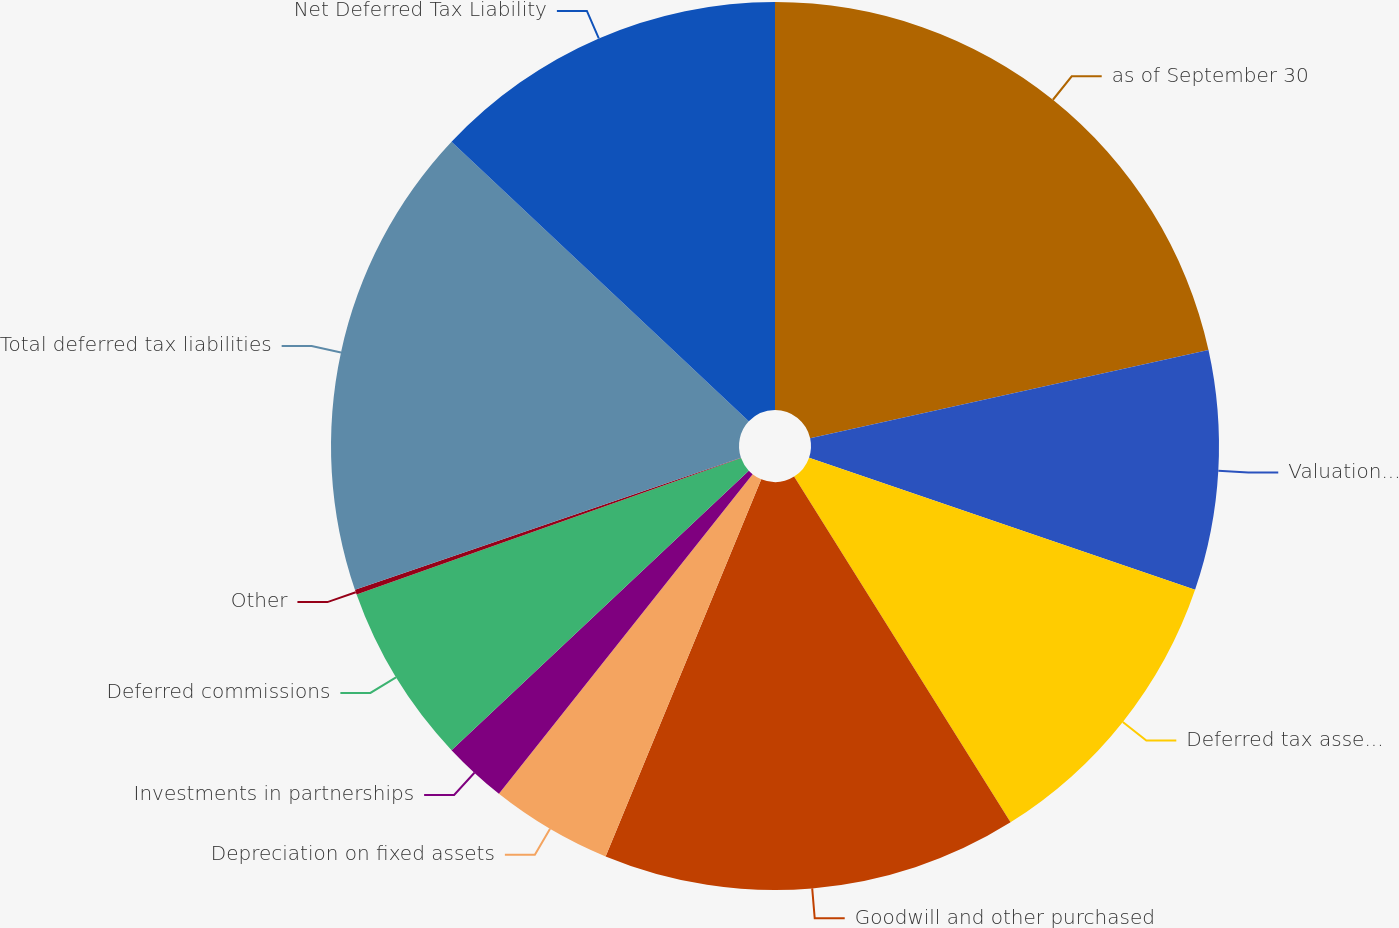Convert chart. <chart><loc_0><loc_0><loc_500><loc_500><pie_chart><fcel>as of September 30<fcel>Valuation allowance for net<fcel>Deferred tax assets net of<fcel>Goodwill and other purchased<fcel>Depreciation on fixed assets<fcel>Investments in partnerships<fcel>Deferred commissions<fcel>Other<fcel>Total deferred tax liabilities<fcel>Net Deferred Tax Liability<nl><fcel>21.53%<fcel>8.72%<fcel>10.85%<fcel>15.13%<fcel>4.45%<fcel>2.31%<fcel>6.58%<fcel>0.18%<fcel>17.26%<fcel>12.99%<nl></chart> 